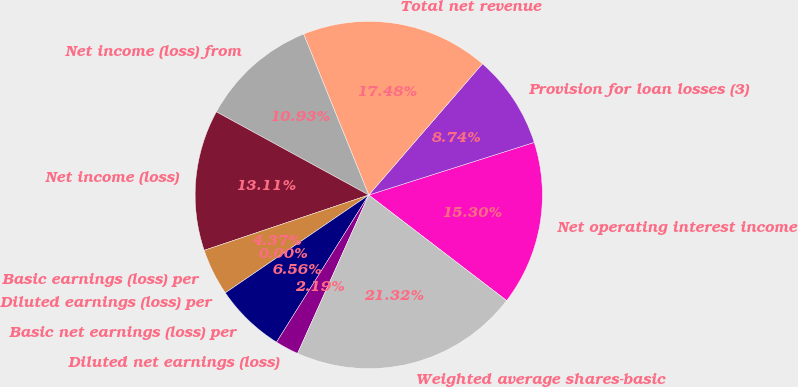<chart> <loc_0><loc_0><loc_500><loc_500><pie_chart><fcel>Net operating interest income<fcel>Provision for loan losses (3)<fcel>Total net revenue<fcel>Net income (loss) from<fcel>Net income (loss)<fcel>Basic earnings (loss) per<fcel>Diluted earnings (loss) per<fcel>Basic net earnings (loss) per<fcel>Diluted net earnings (loss)<fcel>Weighted average shares-basic<nl><fcel>15.3%<fcel>8.74%<fcel>17.48%<fcel>10.93%<fcel>13.11%<fcel>4.37%<fcel>0.0%<fcel>6.56%<fcel>2.19%<fcel>21.32%<nl></chart> 